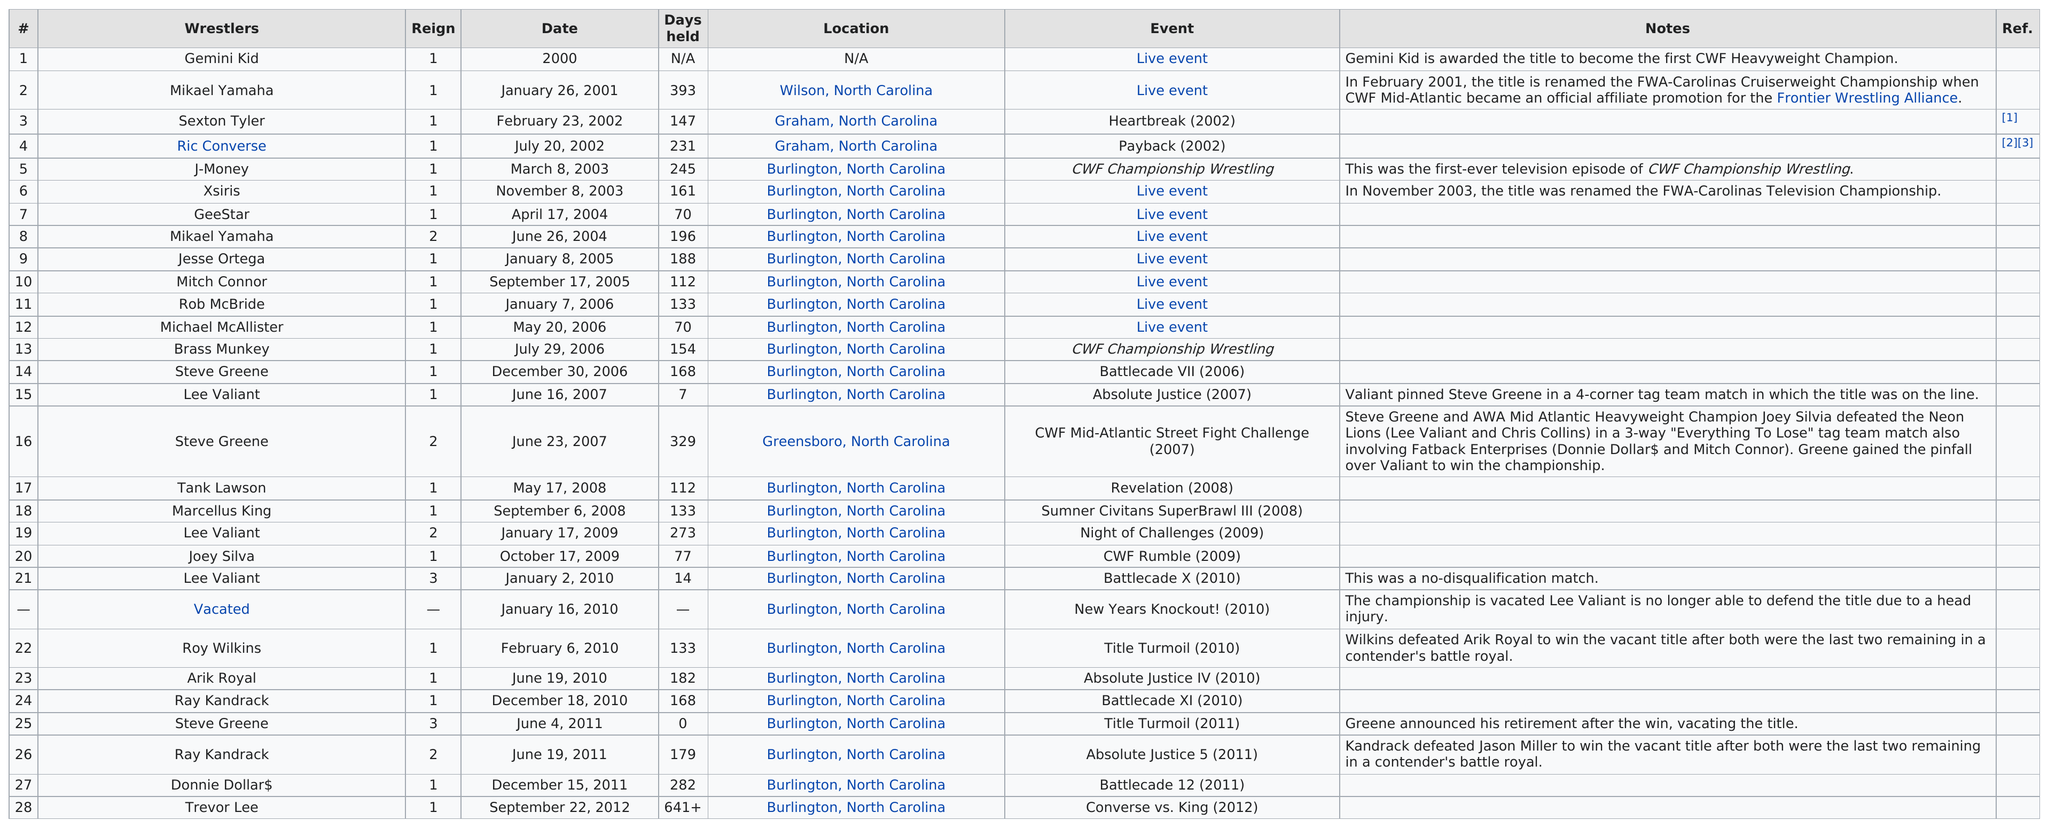Give some essential details in this illustration. In addition to Burlington, events were held in Wilson, North Carolina, Graham, North Carolina, and Greensboro, North Carolina. The list contains at least 16 wrestlers. Yes, there are. In total, there are 28 wrestlers featured on the chart. Gemini Kid is listed first among all wrestlers. On June 23, 2007, the last event was held in Greensboro, North Carolina. 